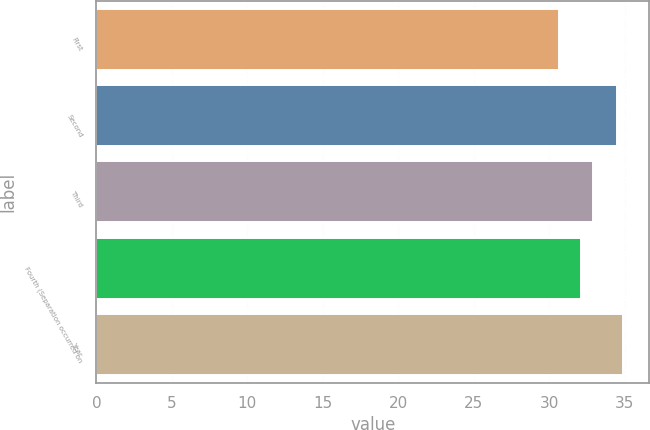Convert chart to OTSL. <chart><loc_0><loc_0><loc_500><loc_500><bar_chart><fcel>First<fcel>Second<fcel>Third<fcel>Fourth (Separation occurred on<fcel>Year<nl><fcel>30.66<fcel>34.5<fcel>32.91<fcel>32.1<fcel>34.88<nl></chart> 